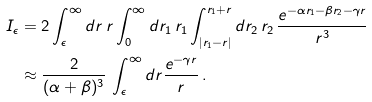<formula> <loc_0><loc_0><loc_500><loc_500>I _ { \epsilon } & = 2 \int _ { \epsilon } ^ { \infty } d r \, r \int _ { 0 } ^ { \infty } d r _ { 1 } \, r _ { 1 } \int _ { | r _ { 1 } - r | } ^ { r _ { 1 } + r } d r _ { 2 } \, r _ { 2 } \, \frac { e ^ { - \alpha r _ { 1 } - \beta r _ { 2 } - \gamma r } } { r ^ { 3 } } \\ & \approx \frac { 2 } { ( \alpha + \beta ) ^ { 3 } } \, \int _ { \epsilon } ^ { \infty } d r \frac { e ^ { - \gamma r } } { r } \, .</formula> 